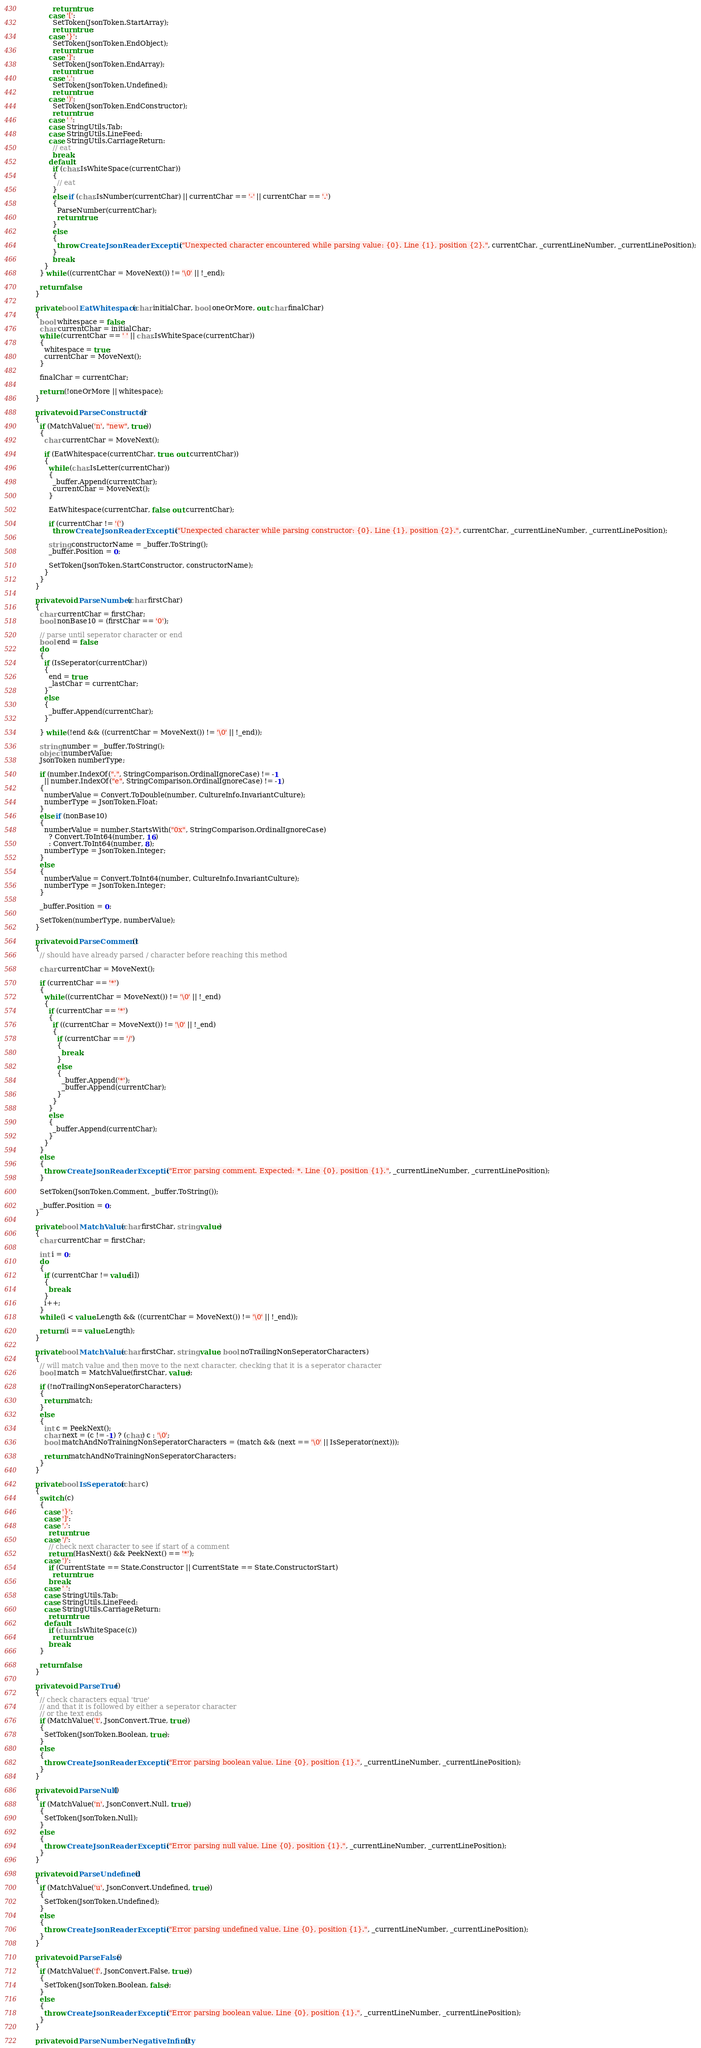<code> <loc_0><loc_0><loc_500><loc_500><_C#_>            return true;
          case '[':
            SetToken(JsonToken.StartArray);
            return true;
          case '}':
            SetToken(JsonToken.EndObject);
            return true;
          case ']':
            SetToken(JsonToken.EndArray);
            return true;
          case ',':
            SetToken(JsonToken.Undefined);
            return true;
          case ')':
            SetToken(JsonToken.EndConstructor);
            return true;
          case ' ':
          case StringUtils.Tab:
          case StringUtils.LineFeed:
          case StringUtils.CarriageReturn:
            // eat
            break;
          default:
            if (char.IsWhiteSpace(currentChar))
            {
              // eat
            }
            else if (char.IsNumber(currentChar) || currentChar == '-' || currentChar == '.')
            {
              ParseNumber(currentChar);
              return true;
            }
            else
            {
              throw CreateJsonReaderException("Unexpected character encountered while parsing value: {0}. Line {1}, position {2}.", currentChar, _currentLineNumber, _currentLinePosition);
            }
            break;
        }
      } while ((currentChar = MoveNext()) != '\0' || !_end);

      return false;
    }

    private bool EatWhitespace(char initialChar, bool oneOrMore, out char finalChar)
    {
      bool whitespace = false;
      char currentChar = initialChar;
      while (currentChar == ' ' || char.IsWhiteSpace(currentChar))
      {
        whitespace = true;
        currentChar = MoveNext();
      }

      finalChar = currentChar;

      return (!oneOrMore || whitespace);
    }

    private void ParseConstructor()
    {
      if (MatchValue('n', "new", true))
      {
        char currentChar = MoveNext();

        if (EatWhitespace(currentChar, true, out currentChar))
        {
          while (char.IsLetter(currentChar))
          {
            _buffer.Append(currentChar);
            currentChar = MoveNext();
          }

          EatWhitespace(currentChar, false, out currentChar);

          if (currentChar != '(')
            throw CreateJsonReaderException("Unexpected character while parsing constructor: {0}. Line {1}, position {2}.", currentChar, _currentLineNumber, _currentLinePosition);

          string constructorName = _buffer.ToString();
          _buffer.Position = 0;

          SetToken(JsonToken.StartConstructor, constructorName);
        }
      }
    }

    private void ParseNumber(char firstChar)
    {
      char currentChar = firstChar;
      bool nonBase10 = (firstChar == '0');

      // parse until seperator character or end
      bool end = false;
      do
      {
        if (IsSeperator(currentChar))
        {
          end = true;
          _lastChar = currentChar;
        }
        else
        {
          _buffer.Append(currentChar);
        }

      } while (!end && ((currentChar = MoveNext()) != '\0' || !_end));

      string number = _buffer.ToString();
      object numberValue;
      JsonToken numberType;

      if (number.IndexOf(".", StringComparison.OrdinalIgnoreCase) != -1
        || number.IndexOf("e", StringComparison.OrdinalIgnoreCase) != -1)
      {
        numberValue = Convert.ToDouble(number, CultureInfo.InvariantCulture);
        numberType = JsonToken.Float;
      }
      else if (nonBase10)
      {
        numberValue = number.StartsWith("0x", StringComparison.OrdinalIgnoreCase)
          ? Convert.ToInt64(number, 16)
          : Convert.ToInt64(number, 8);
        numberType = JsonToken.Integer;
      }
      else
      {
        numberValue = Convert.ToInt64(number, CultureInfo.InvariantCulture);
        numberType = JsonToken.Integer;
      }

      _buffer.Position = 0;

      SetToken(numberType, numberValue);
    }

    private void ParseComment()
    {
      // should have already parsed / character before reaching this method

      char currentChar = MoveNext();

      if (currentChar == '*')
      {
        while ((currentChar = MoveNext()) != '\0' || !_end)
        {
          if (currentChar == '*')
          {
            if ((currentChar = MoveNext()) != '\0' || !_end)
            {
              if (currentChar == '/')
              {
                break;
              }
              else
              {
                _buffer.Append('*');
                _buffer.Append(currentChar);
              }
            }
          }
          else
          {
            _buffer.Append(currentChar);
          }
        }
      }
      else
      {
        throw CreateJsonReaderException("Error parsing comment. Expected: *. Line {0}, position {1}.", _currentLineNumber, _currentLinePosition);
      }

      SetToken(JsonToken.Comment, _buffer.ToString());

      _buffer.Position = 0;
    }

    private bool MatchValue(char firstChar, string value)
    {
      char currentChar = firstChar;

      int i = 0;
      do
      {
        if (currentChar != value[i])
        {
          break;
        }
        i++;
      }
      while (i < value.Length && ((currentChar = MoveNext()) != '\0' || !_end));

      return (i == value.Length);
    }

    private bool MatchValue(char firstChar, string value, bool noTrailingNonSeperatorCharacters)
    {
      // will match value and then move to the next character, checking that it is a seperator character
      bool match = MatchValue(firstChar, value);

      if (!noTrailingNonSeperatorCharacters)
      {
        return match;
      }
      else
      {
        int c = PeekNext();
        char next = (c != -1) ? (char) c : '\0';
        bool matchAndNoTrainingNonSeperatorCharacters = (match && (next == '\0' || IsSeperator(next)));

        return matchAndNoTrainingNonSeperatorCharacters;
      }
    }

    private bool IsSeperator(char c)
    {
      switch (c)
      {
        case '}':
        case ']':
        case ',':
          return true;
        case '/':
          // check next character to see if start of a comment
          return (HasNext() && PeekNext() == '*');
        case ')':
          if (CurrentState == State.Constructor || CurrentState == State.ConstructorStart)
            return true;
          break;
        case ' ':
        case StringUtils.Tab:
        case StringUtils.LineFeed:
        case StringUtils.CarriageReturn:
          return true;
        default:
          if (char.IsWhiteSpace(c))
            return true;
          break;
      }

      return false;
    }

    private void ParseTrue()
    {
      // check characters equal 'true'
      // and that it is followed by either a seperator character
      // or the text ends
      if (MatchValue('t', JsonConvert.True, true))
      {
        SetToken(JsonToken.Boolean, true);
      }
      else
      {
        throw CreateJsonReaderException("Error parsing boolean value. Line {0}, position {1}.", _currentLineNumber, _currentLinePosition);
      }
    }

    private void ParseNull()
    {
      if (MatchValue('n', JsonConvert.Null, true))
      {
        SetToken(JsonToken.Null);
      }
      else
      {
        throw CreateJsonReaderException("Error parsing null value. Line {0}, position {1}.", _currentLineNumber, _currentLinePosition);
      }
    }

    private void ParseUndefined()
    {
      if (MatchValue('u', JsonConvert.Undefined, true))
      {
        SetToken(JsonToken.Undefined);
      }
      else
      {
        throw CreateJsonReaderException("Error parsing undefined value. Line {0}, position {1}.", _currentLineNumber, _currentLinePosition);
      }
    }

    private void ParseFalse()
    {
      if (MatchValue('f', JsonConvert.False, true))
      {
        SetToken(JsonToken.Boolean, false);
      }
      else
      {
        throw CreateJsonReaderException("Error parsing boolean value. Line {0}, position {1}.", _currentLineNumber, _currentLinePosition);
      }
    }

    private void ParseNumberNegativeInfinity()</code> 